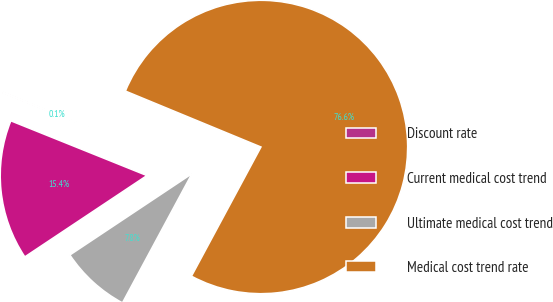Convert chart. <chart><loc_0><loc_0><loc_500><loc_500><pie_chart><fcel>Discount rate<fcel>Current medical cost trend<fcel>Ultimate medical cost trend<fcel>Medical cost trend rate<nl><fcel>0.14%<fcel>15.44%<fcel>7.79%<fcel>76.63%<nl></chart> 